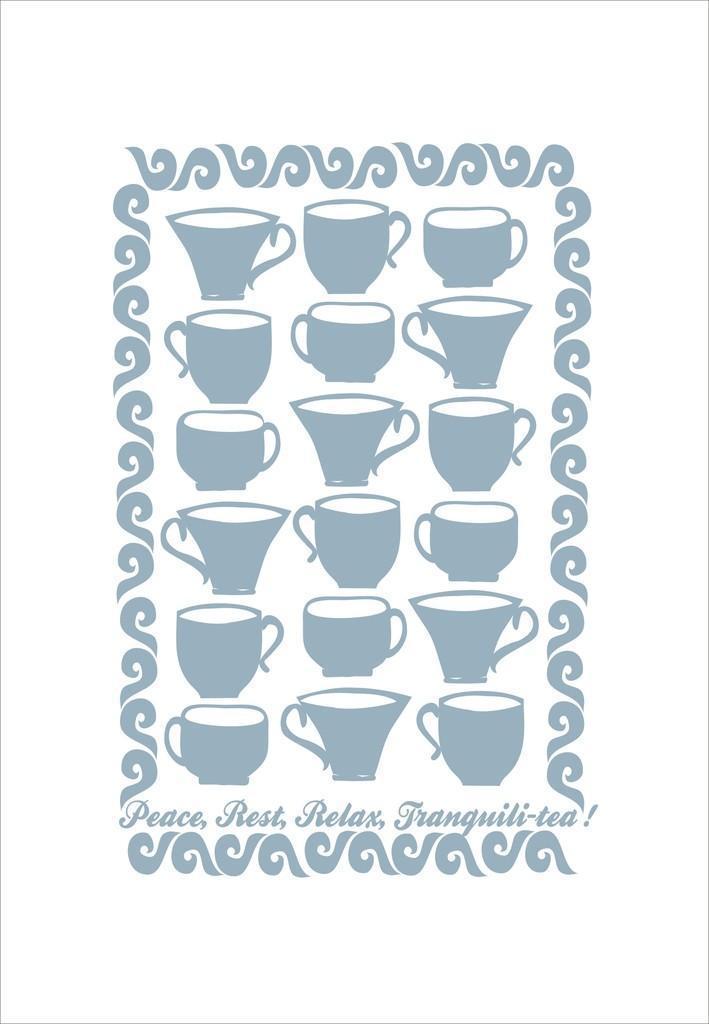In one or two sentences, can you explain what this image depicts? In this image we can see poster with different types of cups. Also there is text. 